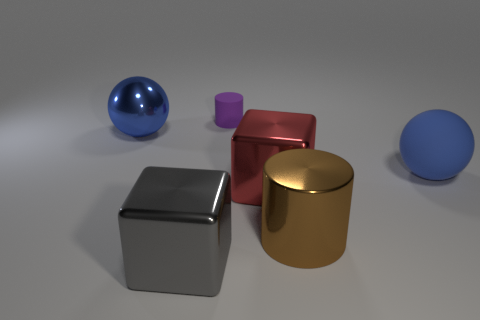What number of red things have the same shape as the gray shiny object?
Ensure brevity in your answer.  1. Are there any big gray objects made of the same material as the large gray block?
Your answer should be compact. No. The large metallic thing that is the same color as the rubber ball is what shape?
Provide a succinct answer. Sphere. How many big metal things are there?
Ensure brevity in your answer.  4. How many balls are either tiny purple things or rubber things?
Your answer should be very brief. 1. What is the color of the rubber sphere that is the same size as the brown metal thing?
Ensure brevity in your answer.  Blue. How many blue objects are both to the right of the purple matte cylinder and to the left of the rubber ball?
Your answer should be compact. 0. What is the material of the tiny purple thing?
Provide a succinct answer. Rubber. How many things are red shiny things or small green cubes?
Provide a short and direct response. 1. There is a cylinder that is in front of the big blue metallic object; is its size the same as the rubber object on the left side of the rubber sphere?
Ensure brevity in your answer.  No. 